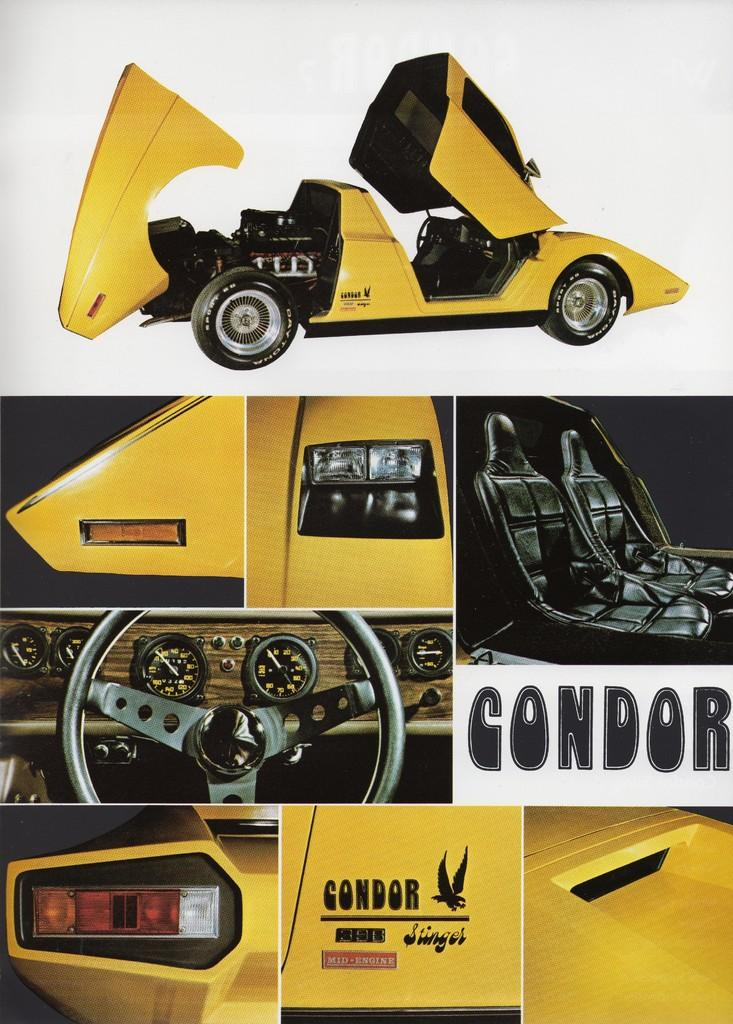What type of artwork is shown in the image? The image is a collage of images. What subject matter is included in the collage? The collage includes various parts of a car. Where is the car located within the collage? The car is at the top of the collage. What type of thread is used to hold the sand together in the image? There is no thread or sand present in the image; it is a collage of car parts. How does the brake system function in the image? The image is a collage of car parts and does not show a functioning brake system. 